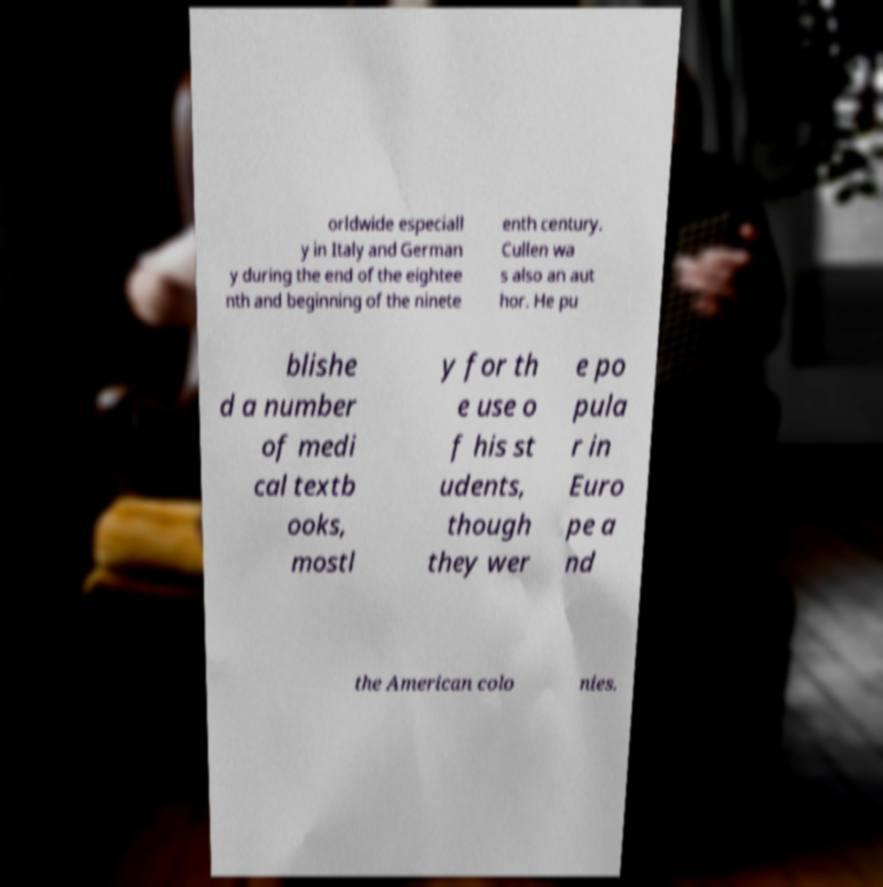For documentation purposes, I need the text within this image transcribed. Could you provide that? orldwide especiall y in Italy and German y during the end of the eightee nth and beginning of the ninete enth century. Cullen wa s also an aut hor. He pu blishe d a number of medi cal textb ooks, mostl y for th e use o f his st udents, though they wer e po pula r in Euro pe a nd the American colo nies. 